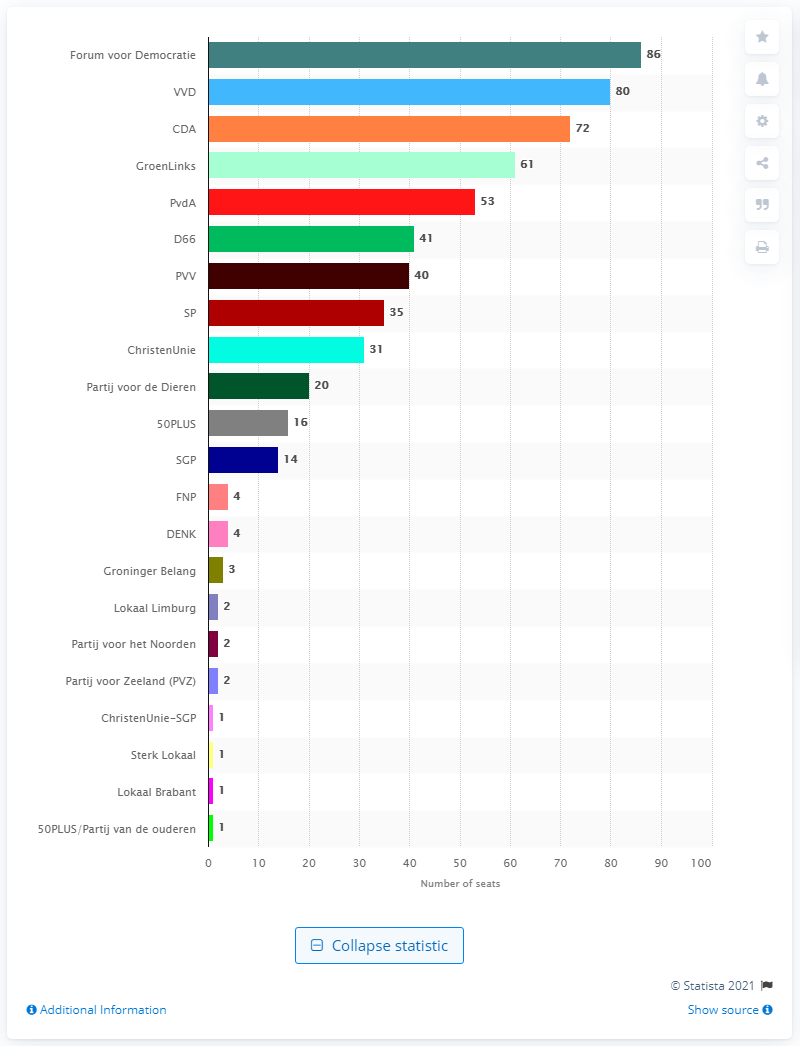Indicate a few pertinent items in this graphic. The People's Party for Freedom and Democracy won 80 seats in the election. What became the largest party in the States-Provincial was Forum voor Democratie. 